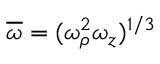<formula> <loc_0><loc_0><loc_500><loc_500>\overline { \omega } = ( \omega _ { \rho } ^ { 2 } \omega _ { z } ) ^ { 1 / 3 }</formula> 